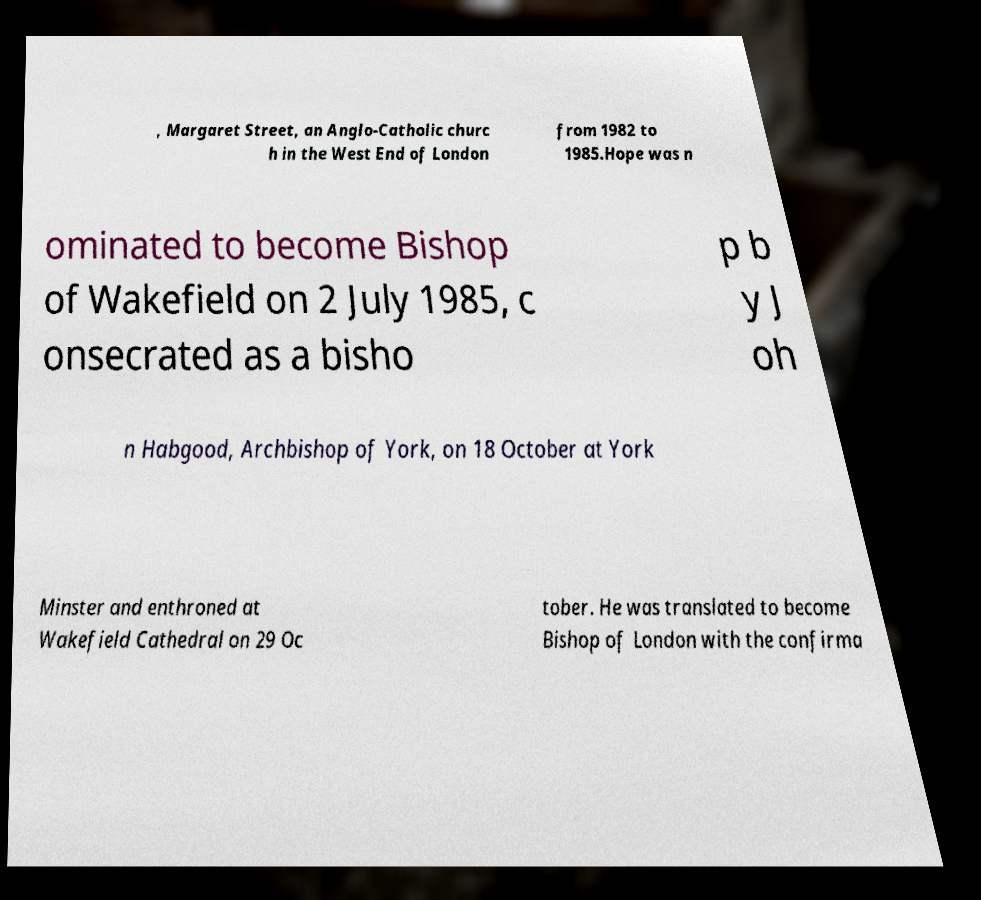There's text embedded in this image that I need extracted. Can you transcribe it verbatim? , Margaret Street, an Anglo-Catholic churc h in the West End of London from 1982 to 1985.Hope was n ominated to become Bishop of Wakefield on 2 July 1985, c onsecrated as a bisho p b y J oh n Habgood, Archbishop of York, on 18 October at York Minster and enthroned at Wakefield Cathedral on 29 Oc tober. He was translated to become Bishop of London with the confirma 